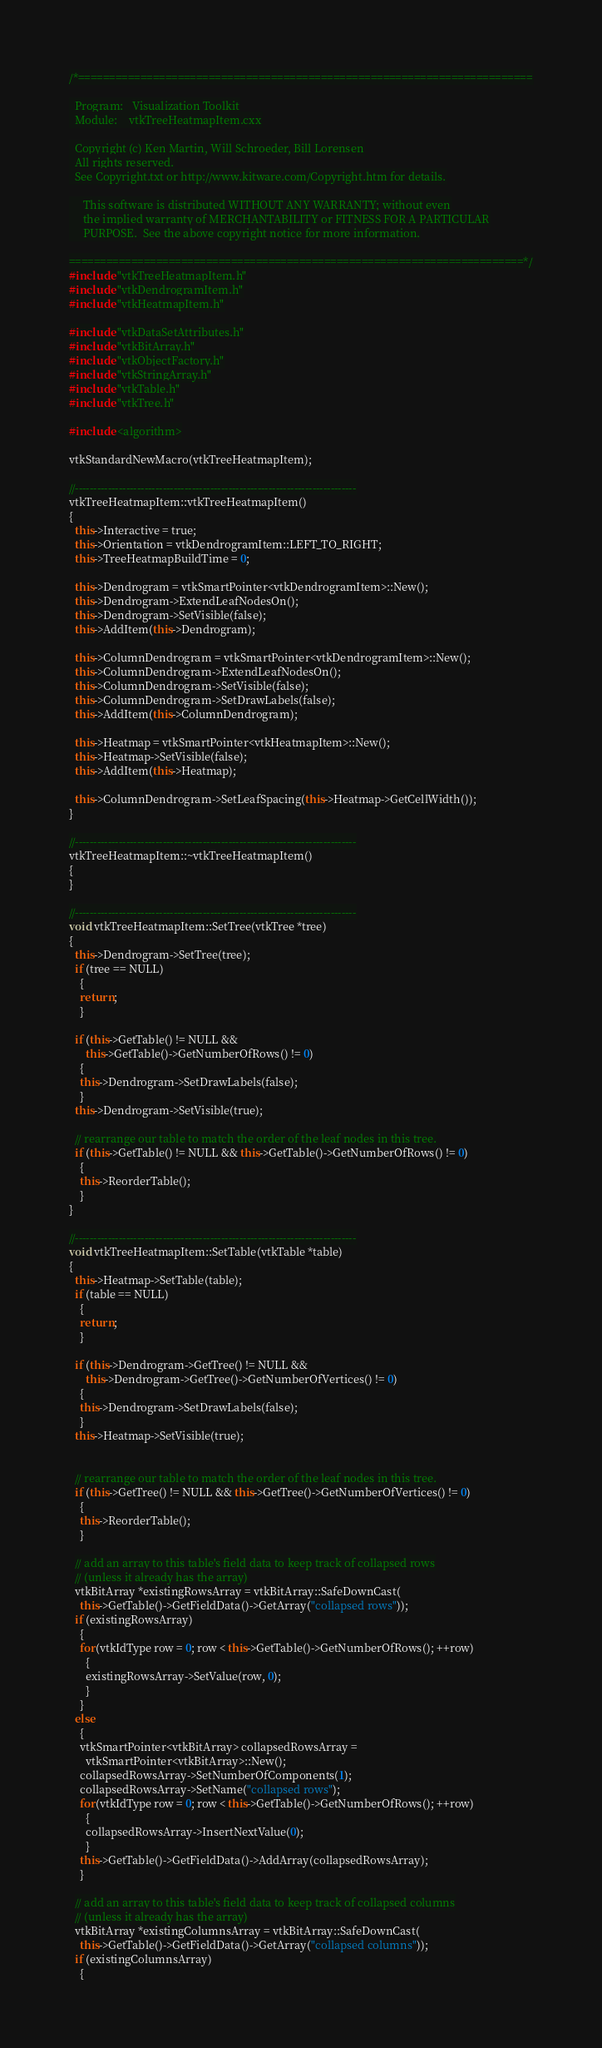Convert code to text. <code><loc_0><loc_0><loc_500><loc_500><_C++_>/*=========================================================================

  Program:   Visualization Toolkit
  Module:    vtkTreeHeatmapItem.cxx

  Copyright (c) Ken Martin, Will Schroeder, Bill Lorensen
  All rights reserved.
  See Copyright.txt or http://www.kitware.com/Copyright.htm for details.

     This software is distributed WITHOUT ANY WARRANTY; without even
     the implied warranty of MERCHANTABILITY or FITNESS FOR A PARTICULAR
     PURPOSE.  See the above copyright notice for more information.

=========================================================================*/
#include "vtkTreeHeatmapItem.h"
#include "vtkDendrogramItem.h"
#include "vtkHeatmapItem.h"

#include "vtkDataSetAttributes.h"
#include "vtkBitArray.h"
#include "vtkObjectFactory.h"
#include "vtkStringArray.h"
#include "vtkTable.h"
#include "vtkTree.h"

#include <algorithm>

vtkStandardNewMacro(vtkTreeHeatmapItem);

//-----------------------------------------------------------------------------
vtkTreeHeatmapItem::vtkTreeHeatmapItem()
{
  this->Interactive = true;
  this->Orientation = vtkDendrogramItem::LEFT_TO_RIGHT;
  this->TreeHeatmapBuildTime = 0;

  this->Dendrogram = vtkSmartPointer<vtkDendrogramItem>::New();
  this->Dendrogram->ExtendLeafNodesOn();
  this->Dendrogram->SetVisible(false);
  this->AddItem(this->Dendrogram);

  this->ColumnDendrogram = vtkSmartPointer<vtkDendrogramItem>::New();
  this->ColumnDendrogram->ExtendLeafNodesOn();
  this->ColumnDendrogram->SetVisible(false);
  this->ColumnDendrogram->SetDrawLabels(false);
  this->AddItem(this->ColumnDendrogram);

  this->Heatmap = vtkSmartPointer<vtkHeatmapItem>::New();
  this->Heatmap->SetVisible(false);
  this->AddItem(this->Heatmap);

  this->ColumnDendrogram->SetLeafSpacing(this->Heatmap->GetCellWidth());
}

//-----------------------------------------------------------------------------
vtkTreeHeatmapItem::~vtkTreeHeatmapItem()
{
}

//-----------------------------------------------------------------------------
void vtkTreeHeatmapItem::SetTree(vtkTree *tree)
{
  this->Dendrogram->SetTree(tree);
  if (tree == NULL)
    {
    return;
    }

  if (this->GetTable() != NULL &&
      this->GetTable()->GetNumberOfRows() != 0)
    {
    this->Dendrogram->SetDrawLabels(false);
    }
  this->Dendrogram->SetVisible(true);

  // rearrange our table to match the order of the leaf nodes in this tree.
  if (this->GetTable() != NULL && this->GetTable()->GetNumberOfRows() != 0)
    {
    this->ReorderTable();
    }
}

//-----------------------------------------------------------------------------
void vtkTreeHeatmapItem::SetTable(vtkTable *table)
{
  this->Heatmap->SetTable(table);
  if (table == NULL)
    {
    return;
    }

  if (this->Dendrogram->GetTree() != NULL &&
      this->Dendrogram->GetTree()->GetNumberOfVertices() != 0)
    {
    this->Dendrogram->SetDrawLabels(false);
    }
  this->Heatmap->SetVisible(true);


  // rearrange our table to match the order of the leaf nodes in this tree.
  if (this->GetTree() != NULL && this->GetTree()->GetNumberOfVertices() != 0)
    {
    this->ReorderTable();
    }

  // add an array to this table's field data to keep track of collapsed rows
  // (unless it already has the array)
  vtkBitArray *existingRowsArray = vtkBitArray::SafeDownCast(
    this->GetTable()->GetFieldData()->GetArray("collapsed rows"));
  if (existingRowsArray)
    {
    for(vtkIdType row = 0; row < this->GetTable()->GetNumberOfRows(); ++row)
      {
      existingRowsArray->SetValue(row, 0);
      }
    }
  else
    {
    vtkSmartPointer<vtkBitArray> collapsedRowsArray =
      vtkSmartPointer<vtkBitArray>::New();
    collapsedRowsArray->SetNumberOfComponents(1);
    collapsedRowsArray->SetName("collapsed rows");
    for(vtkIdType row = 0; row < this->GetTable()->GetNumberOfRows(); ++row)
      {
      collapsedRowsArray->InsertNextValue(0);
      }
    this->GetTable()->GetFieldData()->AddArray(collapsedRowsArray);
    }

  // add an array to this table's field data to keep track of collapsed columns
  // (unless it already has the array)
  vtkBitArray *existingColumnsArray = vtkBitArray::SafeDownCast(
    this->GetTable()->GetFieldData()->GetArray("collapsed columns"));
  if (existingColumnsArray)
    {</code> 